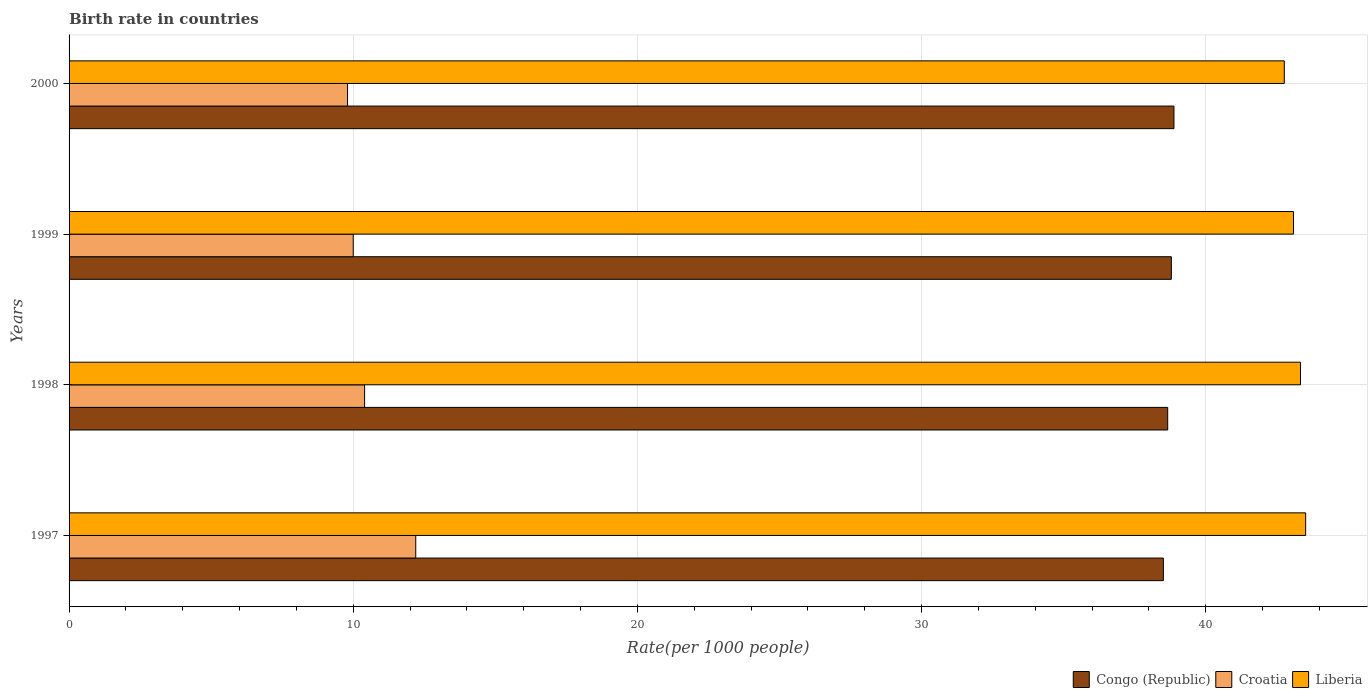How many different coloured bars are there?
Keep it short and to the point. 3. How many groups of bars are there?
Provide a succinct answer. 4. Are the number of bars per tick equal to the number of legend labels?
Your response must be concise. Yes. Are the number of bars on each tick of the Y-axis equal?
Ensure brevity in your answer.  Yes. How many bars are there on the 2nd tick from the bottom?
Your response must be concise. 3. What is the birth rate in Congo (Republic) in 1998?
Keep it short and to the point. 38.66. Across all years, what is the maximum birth rate in Croatia?
Give a very brief answer. 12.2. In which year was the birth rate in Congo (Republic) minimum?
Provide a succinct answer. 1997. What is the total birth rate in Croatia in the graph?
Provide a succinct answer. 42.4. What is the difference between the birth rate in Congo (Republic) in 1997 and that in 1998?
Make the answer very short. -0.15. What is the difference between the birth rate in Liberia in 1998 and the birth rate in Congo (Republic) in 1997?
Offer a terse response. 4.83. What is the average birth rate in Congo (Republic) per year?
Provide a short and direct response. 38.71. In the year 1997, what is the difference between the birth rate in Croatia and birth rate in Liberia?
Ensure brevity in your answer.  -31.32. What is the ratio of the birth rate in Croatia in 1998 to that in 2000?
Your answer should be compact. 1.06. Is the difference between the birth rate in Croatia in 1997 and 1999 greater than the difference between the birth rate in Liberia in 1997 and 1999?
Give a very brief answer. Yes. What is the difference between the highest and the second highest birth rate in Croatia?
Your answer should be compact. 1.8. What is the difference between the highest and the lowest birth rate in Congo (Republic)?
Keep it short and to the point. 0.37. What does the 1st bar from the top in 1997 represents?
Offer a terse response. Liberia. What does the 3rd bar from the bottom in 1998 represents?
Make the answer very short. Liberia. Is it the case that in every year, the sum of the birth rate in Congo (Republic) and birth rate in Croatia is greater than the birth rate in Liberia?
Provide a short and direct response. Yes. Are all the bars in the graph horizontal?
Give a very brief answer. Yes. How many years are there in the graph?
Your response must be concise. 4. How many legend labels are there?
Your answer should be very brief. 3. How are the legend labels stacked?
Ensure brevity in your answer.  Horizontal. What is the title of the graph?
Your answer should be compact. Birth rate in countries. What is the label or title of the X-axis?
Your answer should be very brief. Rate(per 1000 people). What is the label or title of the Y-axis?
Offer a terse response. Years. What is the Rate(per 1000 people) of Congo (Republic) in 1997?
Provide a short and direct response. 38.51. What is the Rate(per 1000 people) in Liberia in 1997?
Keep it short and to the point. 43.52. What is the Rate(per 1000 people) in Congo (Republic) in 1998?
Your answer should be very brief. 38.66. What is the Rate(per 1000 people) of Liberia in 1998?
Keep it short and to the point. 43.34. What is the Rate(per 1000 people) of Congo (Republic) in 1999?
Your answer should be very brief. 38.79. What is the Rate(per 1000 people) of Liberia in 1999?
Offer a terse response. 43.09. What is the Rate(per 1000 people) of Congo (Republic) in 2000?
Offer a terse response. 38.88. What is the Rate(per 1000 people) of Liberia in 2000?
Provide a succinct answer. 42.77. Across all years, what is the maximum Rate(per 1000 people) in Congo (Republic)?
Offer a very short reply. 38.88. Across all years, what is the maximum Rate(per 1000 people) of Liberia?
Provide a short and direct response. 43.52. Across all years, what is the minimum Rate(per 1000 people) in Congo (Republic)?
Provide a short and direct response. 38.51. Across all years, what is the minimum Rate(per 1000 people) of Croatia?
Make the answer very short. 9.8. Across all years, what is the minimum Rate(per 1000 people) of Liberia?
Provide a succinct answer. 42.77. What is the total Rate(per 1000 people) in Congo (Republic) in the graph?
Ensure brevity in your answer.  154.84. What is the total Rate(per 1000 people) in Croatia in the graph?
Give a very brief answer. 42.4. What is the total Rate(per 1000 people) of Liberia in the graph?
Your response must be concise. 172.71. What is the difference between the Rate(per 1000 people) of Congo (Republic) in 1997 and that in 1998?
Offer a terse response. -0.15. What is the difference between the Rate(per 1000 people) in Liberia in 1997 and that in 1998?
Keep it short and to the point. 0.18. What is the difference between the Rate(per 1000 people) in Congo (Republic) in 1997 and that in 1999?
Your answer should be very brief. -0.28. What is the difference between the Rate(per 1000 people) in Croatia in 1997 and that in 1999?
Keep it short and to the point. 2.2. What is the difference between the Rate(per 1000 people) of Liberia in 1997 and that in 1999?
Your answer should be very brief. 0.43. What is the difference between the Rate(per 1000 people) of Congo (Republic) in 1997 and that in 2000?
Your answer should be compact. -0.37. What is the difference between the Rate(per 1000 people) of Croatia in 1997 and that in 2000?
Your answer should be compact. 2.4. What is the difference between the Rate(per 1000 people) in Liberia in 1997 and that in 2000?
Offer a very short reply. 0.75. What is the difference between the Rate(per 1000 people) of Congo (Republic) in 1998 and that in 1999?
Offer a terse response. -0.13. What is the difference between the Rate(per 1000 people) of Liberia in 1998 and that in 1999?
Make the answer very short. 0.25. What is the difference between the Rate(per 1000 people) in Congo (Republic) in 1998 and that in 2000?
Make the answer very short. -0.22. What is the difference between the Rate(per 1000 people) of Liberia in 1998 and that in 2000?
Ensure brevity in your answer.  0.57. What is the difference between the Rate(per 1000 people) of Congo (Republic) in 1999 and that in 2000?
Your response must be concise. -0.09. What is the difference between the Rate(per 1000 people) in Liberia in 1999 and that in 2000?
Offer a very short reply. 0.32. What is the difference between the Rate(per 1000 people) of Congo (Republic) in 1997 and the Rate(per 1000 people) of Croatia in 1998?
Give a very brief answer. 28.11. What is the difference between the Rate(per 1000 people) in Congo (Republic) in 1997 and the Rate(per 1000 people) in Liberia in 1998?
Your answer should be compact. -4.83. What is the difference between the Rate(per 1000 people) in Croatia in 1997 and the Rate(per 1000 people) in Liberia in 1998?
Your answer should be compact. -31.14. What is the difference between the Rate(per 1000 people) in Congo (Republic) in 1997 and the Rate(per 1000 people) in Croatia in 1999?
Offer a very short reply. 28.51. What is the difference between the Rate(per 1000 people) in Congo (Republic) in 1997 and the Rate(per 1000 people) in Liberia in 1999?
Make the answer very short. -4.58. What is the difference between the Rate(per 1000 people) in Croatia in 1997 and the Rate(per 1000 people) in Liberia in 1999?
Provide a short and direct response. -30.89. What is the difference between the Rate(per 1000 people) of Congo (Republic) in 1997 and the Rate(per 1000 people) of Croatia in 2000?
Keep it short and to the point. 28.71. What is the difference between the Rate(per 1000 people) in Congo (Republic) in 1997 and the Rate(per 1000 people) in Liberia in 2000?
Provide a short and direct response. -4.26. What is the difference between the Rate(per 1000 people) in Croatia in 1997 and the Rate(per 1000 people) in Liberia in 2000?
Your answer should be very brief. -30.57. What is the difference between the Rate(per 1000 people) in Congo (Republic) in 1998 and the Rate(per 1000 people) in Croatia in 1999?
Make the answer very short. 28.66. What is the difference between the Rate(per 1000 people) in Congo (Republic) in 1998 and the Rate(per 1000 people) in Liberia in 1999?
Make the answer very short. -4.43. What is the difference between the Rate(per 1000 people) of Croatia in 1998 and the Rate(per 1000 people) of Liberia in 1999?
Ensure brevity in your answer.  -32.69. What is the difference between the Rate(per 1000 people) in Congo (Republic) in 1998 and the Rate(per 1000 people) in Croatia in 2000?
Your answer should be very brief. 28.86. What is the difference between the Rate(per 1000 people) in Congo (Republic) in 1998 and the Rate(per 1000 people) in Liberia in 2000?
Your answer should be very brief. -4.1. What is the difference between the Rate(per 1000 people) in Croatia in 1998 and the Rate(per 1000 people) in Liberia in 2000?
Provide a short and direct response. -32.37. What is the difference between the Rate(per 1000 people) of Congo (Republic) in 1999 and the Rate(per 1000 people) of Croatia in 2000?
Your response must be concise. 28.99. What is the difference between the Rate(per 1000 people) of Congo (Republic) in 1999 and the Rate(per 1000 people) of Liberia in 2000?
Give a very brief answer. -3.98. What is the difference between the Rate(per 1000 people) of Croatia in 1999 and the Rate(per 1000 people) of Liberia in 2000?
Give a very brief answer. -32.77. What is the average Rate(per 1000 people) in Congo (Republic) per year?
Offer a very short reply. 38.71. What is the average Rate(per 1000 people) of Liberia per year?
Your response must be concise. 43.18. In the year 1997, what is the difference between the Rate(per 1000 people) in Congo (Republic) and Rate(per 1000 people) in Croatia?
Provide a succinct answer. 26.31. In the year 1997, what is the difference between the Rate(per 1000 people) in Congo (Republic) and Rate(per 1000 people) in Liberia?
Give a very brief answer. -5.01. In the year 1997, what is the difference between the Rate(per 1000 people) of Croatia and Rate(per 1000 people) of Liberia?
Give a very brief answer. -31.32. In the year 1998, what is the difference between the Rate(per 1000 people) of Congo (Republic) and Rate(per 1000 people) of Croatia?
Provide a succinct answer. 28.26. In the year 1998, what is the difference between the Rate(per 1000 people) of Congo (Republic) and Rate(per 1000 people) of Liberia?
Your response must be concise. -4.67. In the year 1998, what is the difference between the Rate(per 1000 people) in Croatia and Rate(per 1000 people) in Liberia?
Your answer should be compact. -32.94. In the year 1999, what is the difference between the Rate(per 1000 people) of Congo (Republic) and Rate(per 1000 people) of Croatia?
Make the answer very short. 28.79. In the year 1999, what is the difference between the Rate(per 1000 people) in Congo (Republic) and Rate(per 1000 people) in Liberia?
Offer a terse response. -4.3. In the year 1999, what is the difference between the Rate(per 1000 people) in Croatia and Rate(per 1000 people) in Liberia?
Make the answer very short. -33.09. In the year 2000, what is the difference between the Rate(per 1000 people) in Congo (Republic) and Rate(per 1000 people) in Croatia?
Provide a short and direct response. 29.08. In the year 2000, what is the difference between the Rate(per 1000 people) of Congo (Republic) and Rate(per 1000 people) of Liberia?
Offer a terse response. -3.88. In the year 2000, what is the difference between the Rate(per 1000 people) of Croatia and Rate(per 1000 people) of Liberia?
Your answer should be compact. -32.97. What is the ratio of the Rate(per 1000 people) of Congo (Republic) in 1997 to that in 1998?
Keep it short and to the point. 1. What is the ratio of the Rate(per 1000 people) in Croatia in 1997 to that in 1998?
Ensure brevity in your answer.  1.17. What is the ratio of the Rate(per 1000 people) of Liberia in 1997 to that in 1998?
Keep it short and to the point. 1. What is the ratio of the Rate(per 1000 people) of Congo (Republic) in 1997 to that in 1999?
Offer a very short reply. 0.99. What is the ratio of the Rate(per 1000 people) of Croatia in 1997 to that in 1999?
Give a very brief answer. 1.22. What is the ratio of the Rate(per 1000 people) of Liberia in 1997 to that in 1999?
Offer a very short reply. 1.01. What is the ratio of the Rate(per 1000 people) of Congo (Republic) in 1997 to that in 2000?
Your response must be concise. 0.99. What is the ratio of the Rate(per 1000 people) in Croatia in 1997 to that in 2000?
Provide a short and direct response. 1.24. What is the ratio of the Rate(per 1000 people) of Liberia in 1997 to that in 2000?
Keep it short and to the point. 1.02. What is the ratio of the Rate(per 1000 people) in Liberia in 1998 to that in 1999?
Your answer should be very brief. 1.01. What is the ratio of the Rate(per 1000 people) of Congo (Republic) in 1998 to that in 2000?
Your answer should be very brief. 0.99. What is the ratio of the Rate(per 1000 people) in Croatia in 1998 to that in 2000?
Your answer should be compact. 1.06. What is the ratio of the Rate(per 1000 people) in Liberia in 1998 to that in 2000?
Offer a terse response. 1.01. What is the ratio of the Rate(per 1000 people) in Croatia in 1999 to that in 2000?
Offer a terse response. 1.02. What is the ratio of the Rate(per 1000 people) of Liberia in 1999 to that in 2000?
Your answer should be compact. 1.01. What is the difference between the highest and the second highest Rate(per 1000 people) of Congo (Republic)?
Ensure brevity in your answer.  0.09. What is the difference between the highest and the second highest Rate(per 1000 people) of Croatia?
Ensure brevity in your answer.  1.8. What is the difference between the highest and the second highest Rate(per 1000 people) in Liberia?
Your response must be concise. 0.18. What is the difference between the highest and the lowest Rate(per 1000 people) of Congo (Republic)?
Provide a succinct answer. 0.37. What is the difference between the highest and the lowest Rate(per 1000 people) of Liberia?
Offer a terse response. 0.75. 